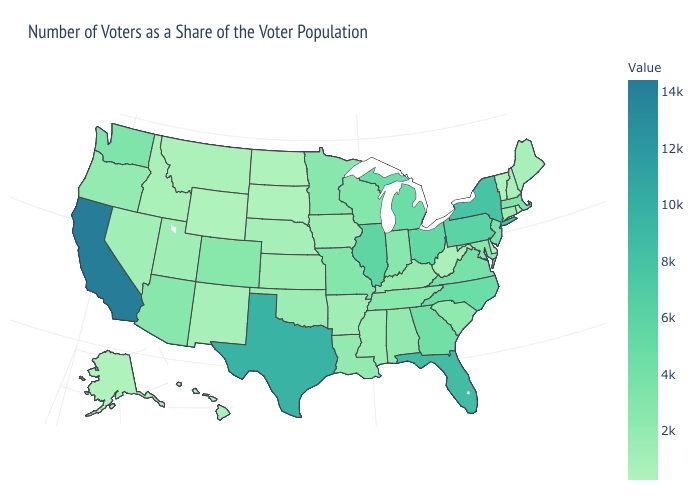Does the map have missing data?
Keep it brief. No. Does North Dakota have the lowest value in the MidWest?
Concise answer only. Yes. Among the states that border North Carolina , which have the highest value?
Quick response, please. Georgia. Does California have the highest value in the West?
Quick response, please. Yes. 